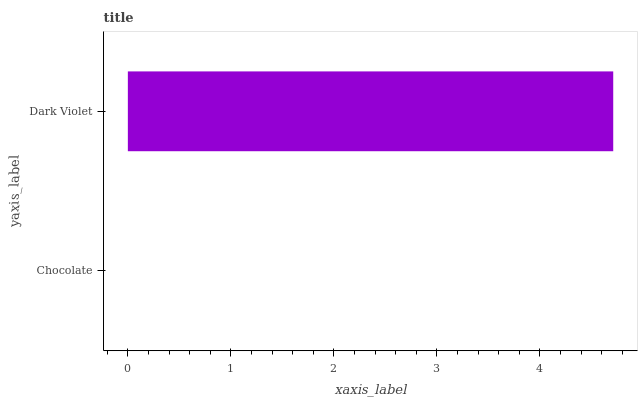Is Chocolate the minimum?
Answer yes or no. Yes. Is Dark Violet the maximum?
Answer yes or no. Yes. Is Dark Violet the minimum?
Answer yes or no. No. Is Dark Violet greater than Chocolate?
Answer yes or no. Yes. Is Chocolate less than Dark Violet?
Answer yes or no. Yes. Is Chocolate greater than Dark Violet?
Answer yes or no. No. Is Dark Violet less than Chocolate?
Answer yes or no. No. Is Dark Violet the high median?
Answer yes or no. Yes. Is Chocolate the low median?
Answer yes or no. Yes. Is Chocolate the high median?
Answer yes or no. No. Is Dark Violet the low median?
Answer yes or no. No. 